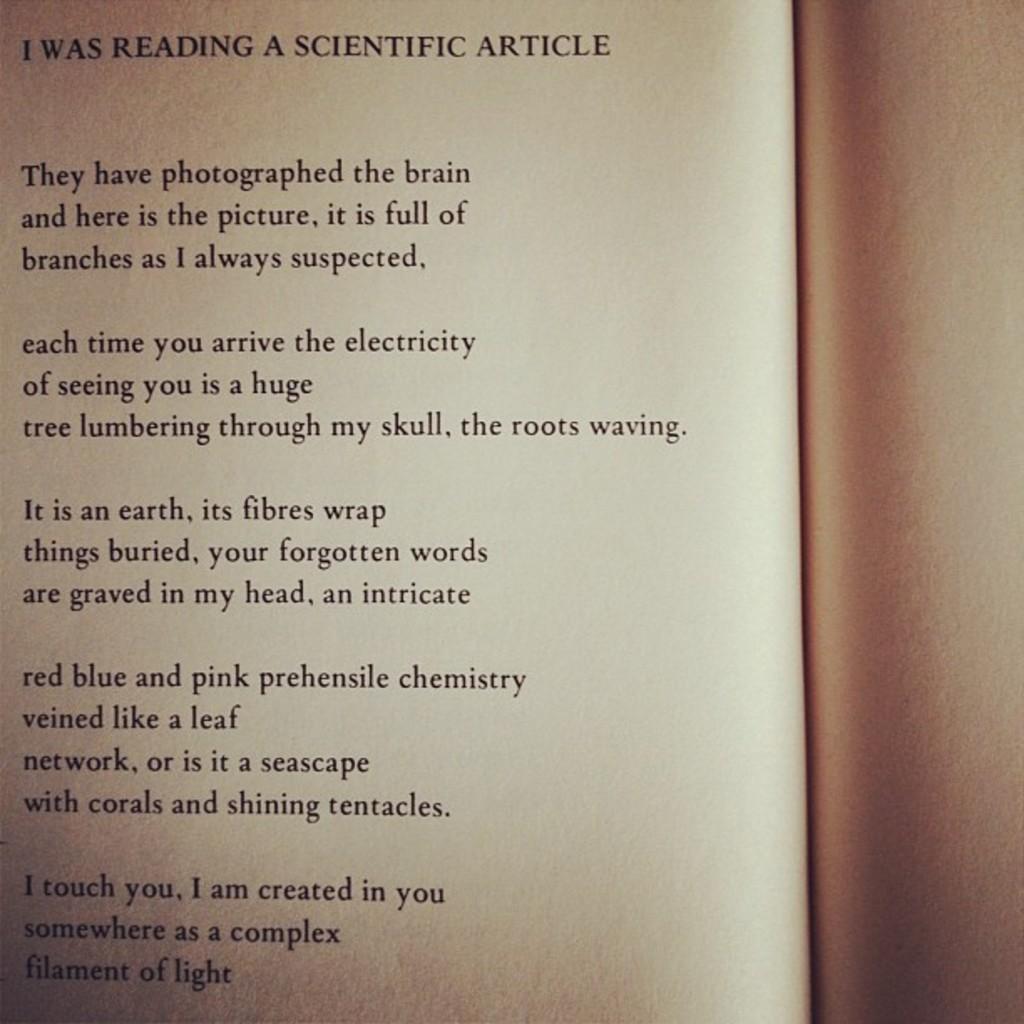What is the title of this page?
Ensure brevity in your answer.  I was reading a scientific article. What is the first sentence of this article?
Provide a succinct answer. They have photographed the brain and here is the picture, it is full of branches as i always suspected. 